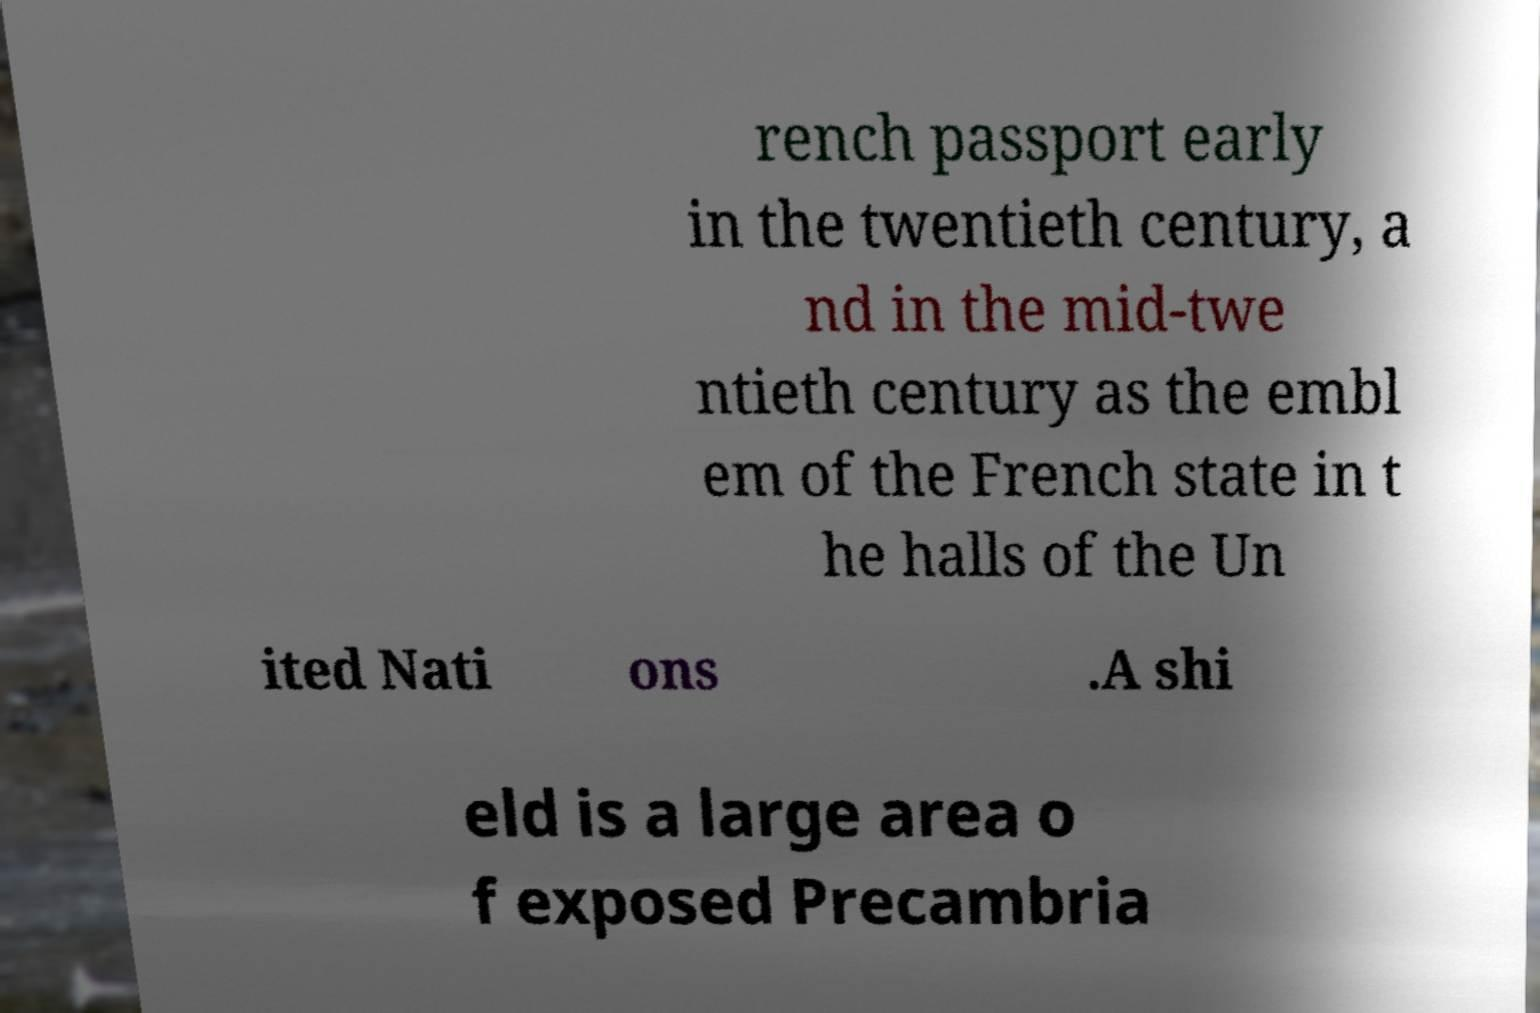For documentation purposes, I need the text within this image transcribed. Could you provide that? rench passport early in the twentieth century, a nd in the mid-twe ntieth century as the embl em of the French state in t he halls of the Un ited Nati ons .A shi eld is a large area o f exposed Precambria 